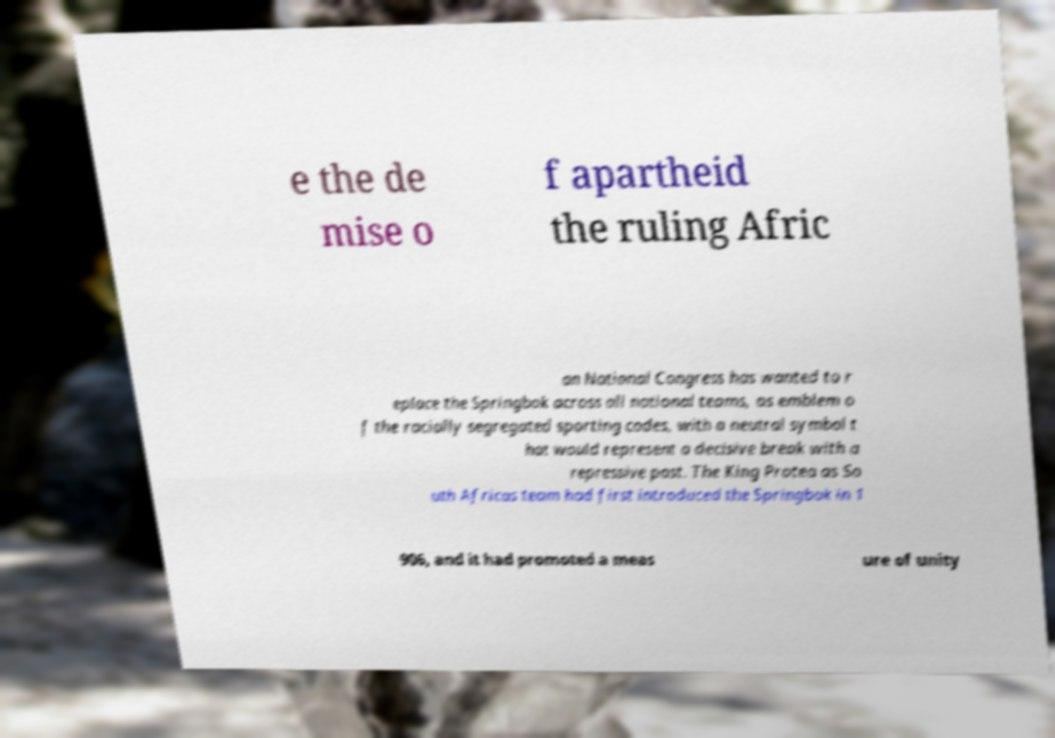Can you read and provide the text displayed in the image?This photo seems to have some interesting text. Can you extract and type it out for me? e the de mise o f apartheid the ruling Afric an National Congress has wanted to r eplace the Springbok across all national teams, as emblem o f the racially segregated sporting codes, with a neutral symbol t hat would represent a decisive break with a repressive past. The King Protea as So uth Africas team had first introduced the Springbok in 1 906, and it had promoted a meas ure of unity 